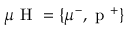Convert formula to latex. <formula><loc_0><loc_0><loc_500><loc_500>\mu H = \{ \mu ^ { - } , p ^ { + } \}</formula> 